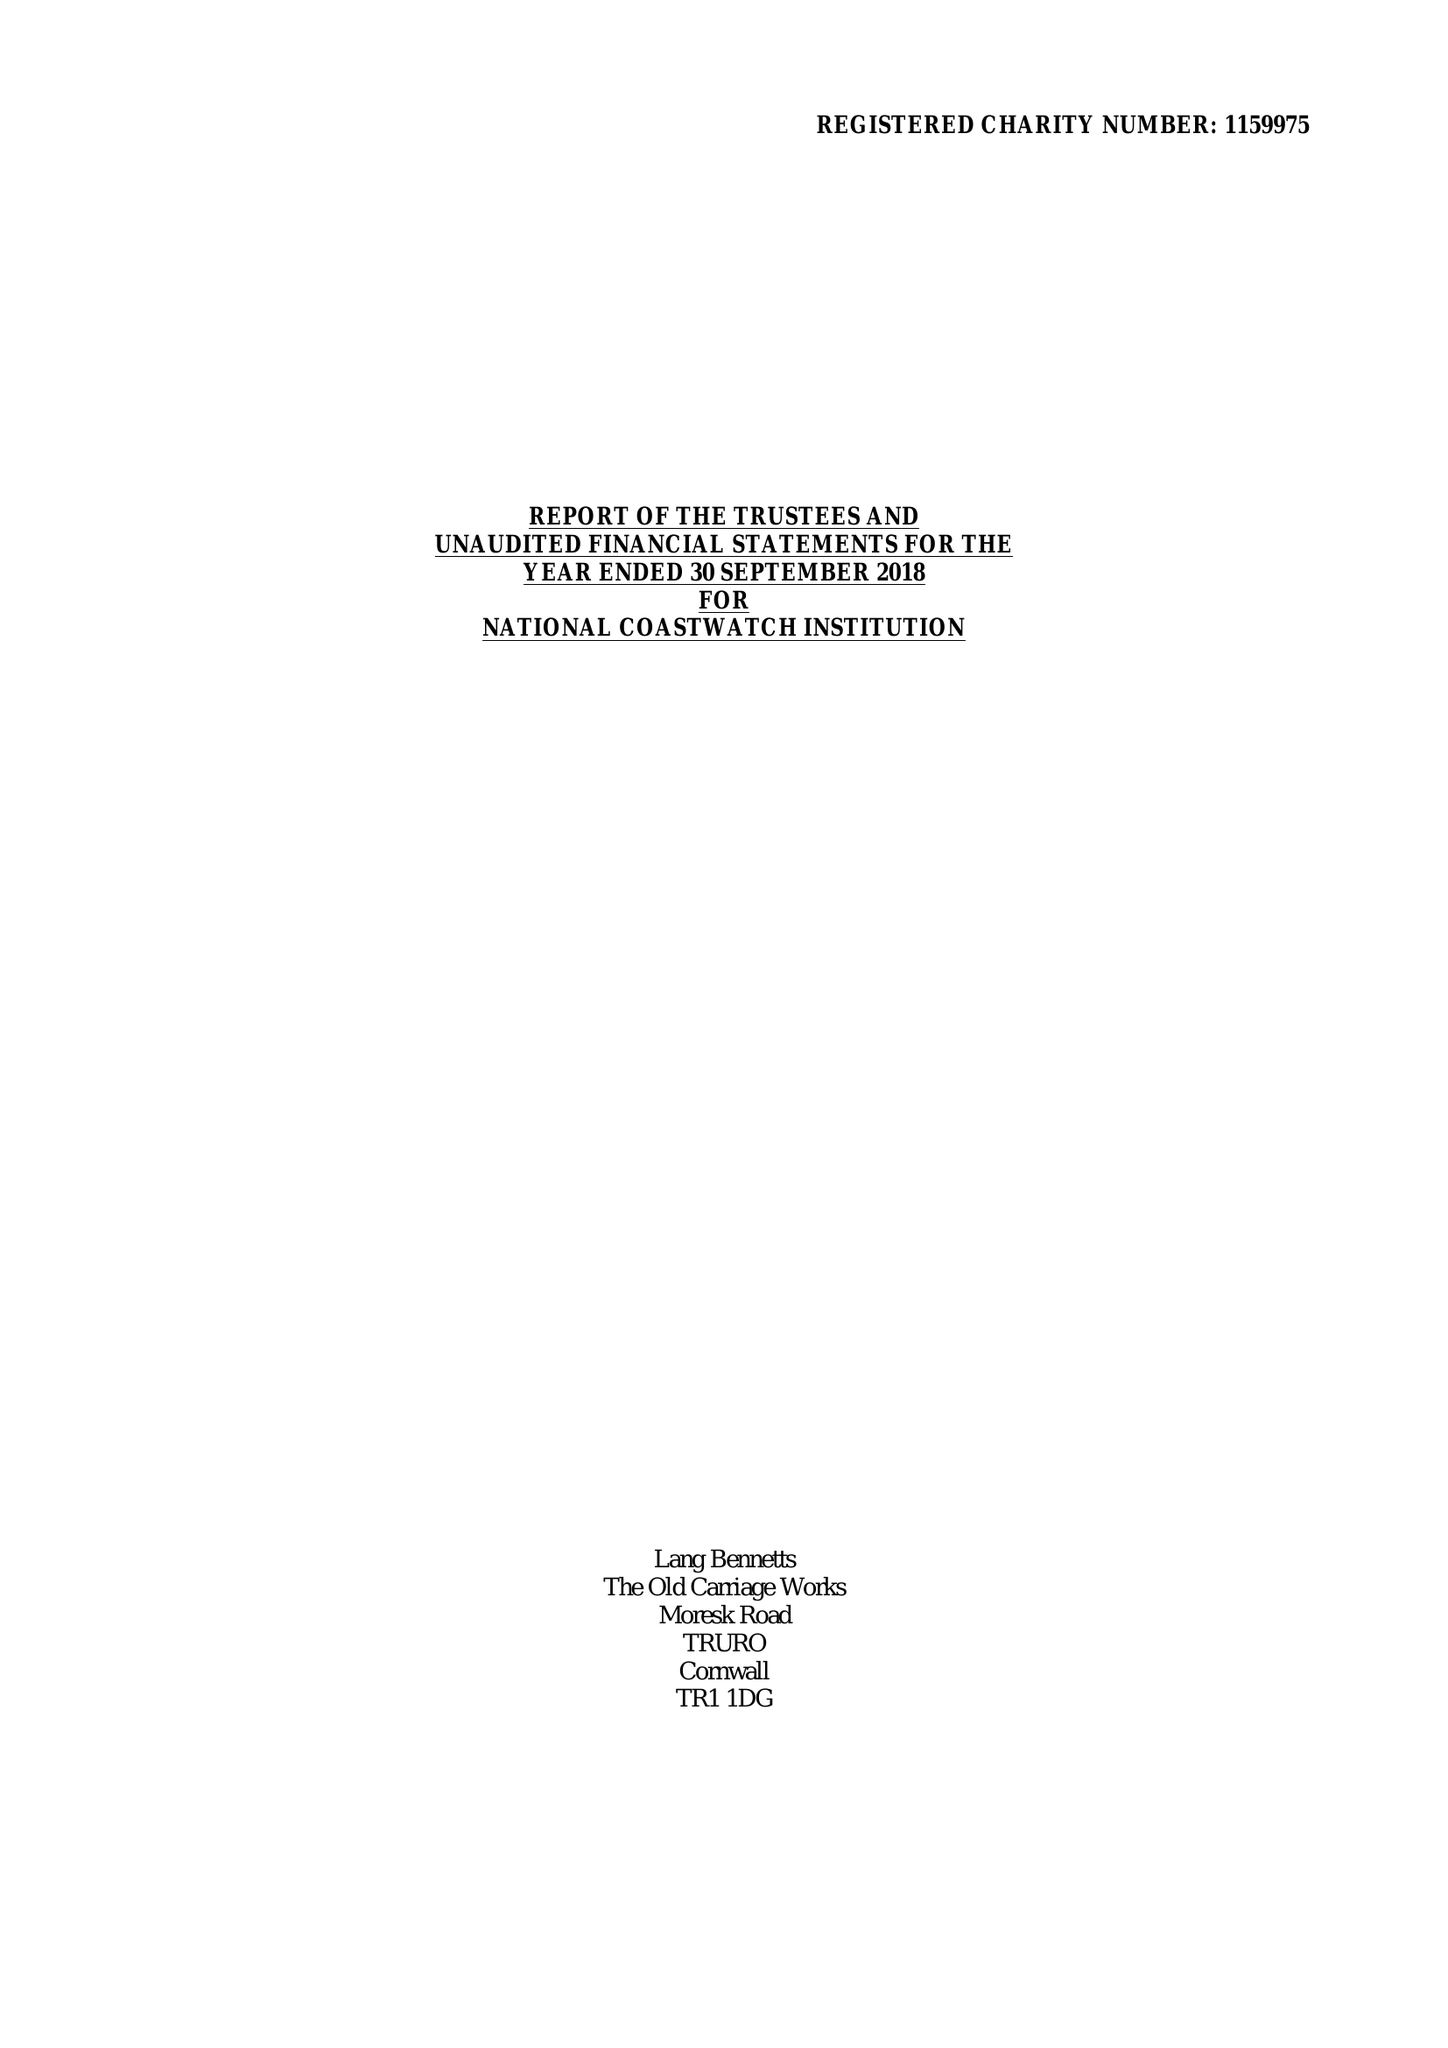What is the value for the address__post_town?
Answer the question using a single word or phrase. LISKEARD 